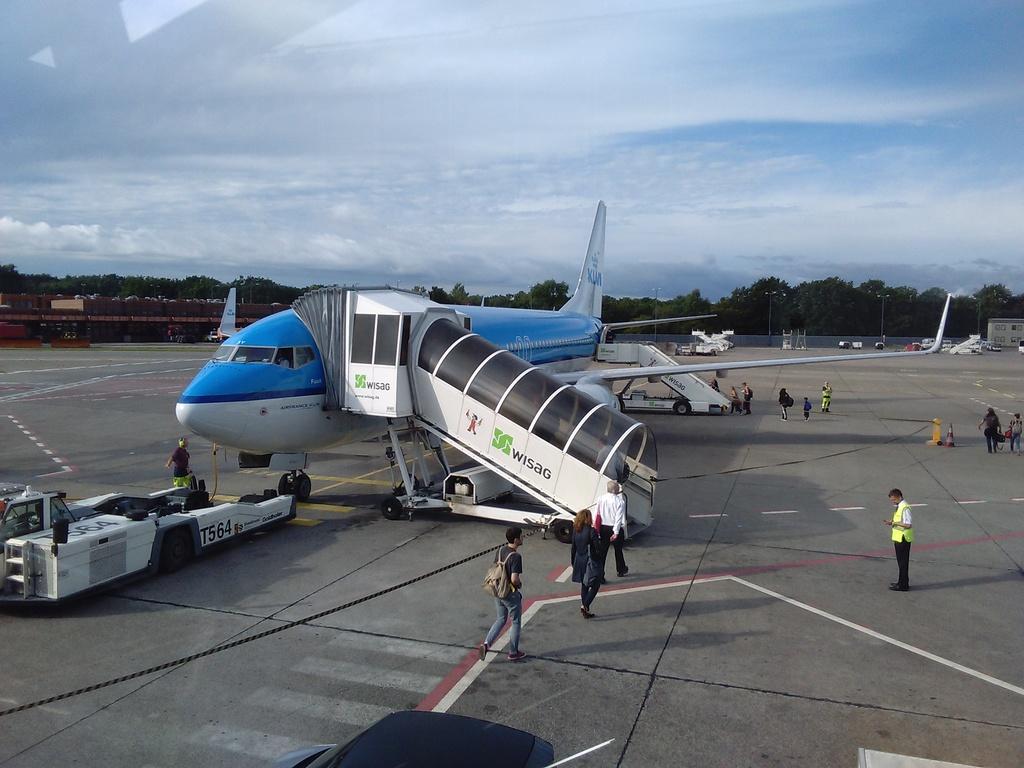What airline is pictured?
Make the answer very short. Wisag. 